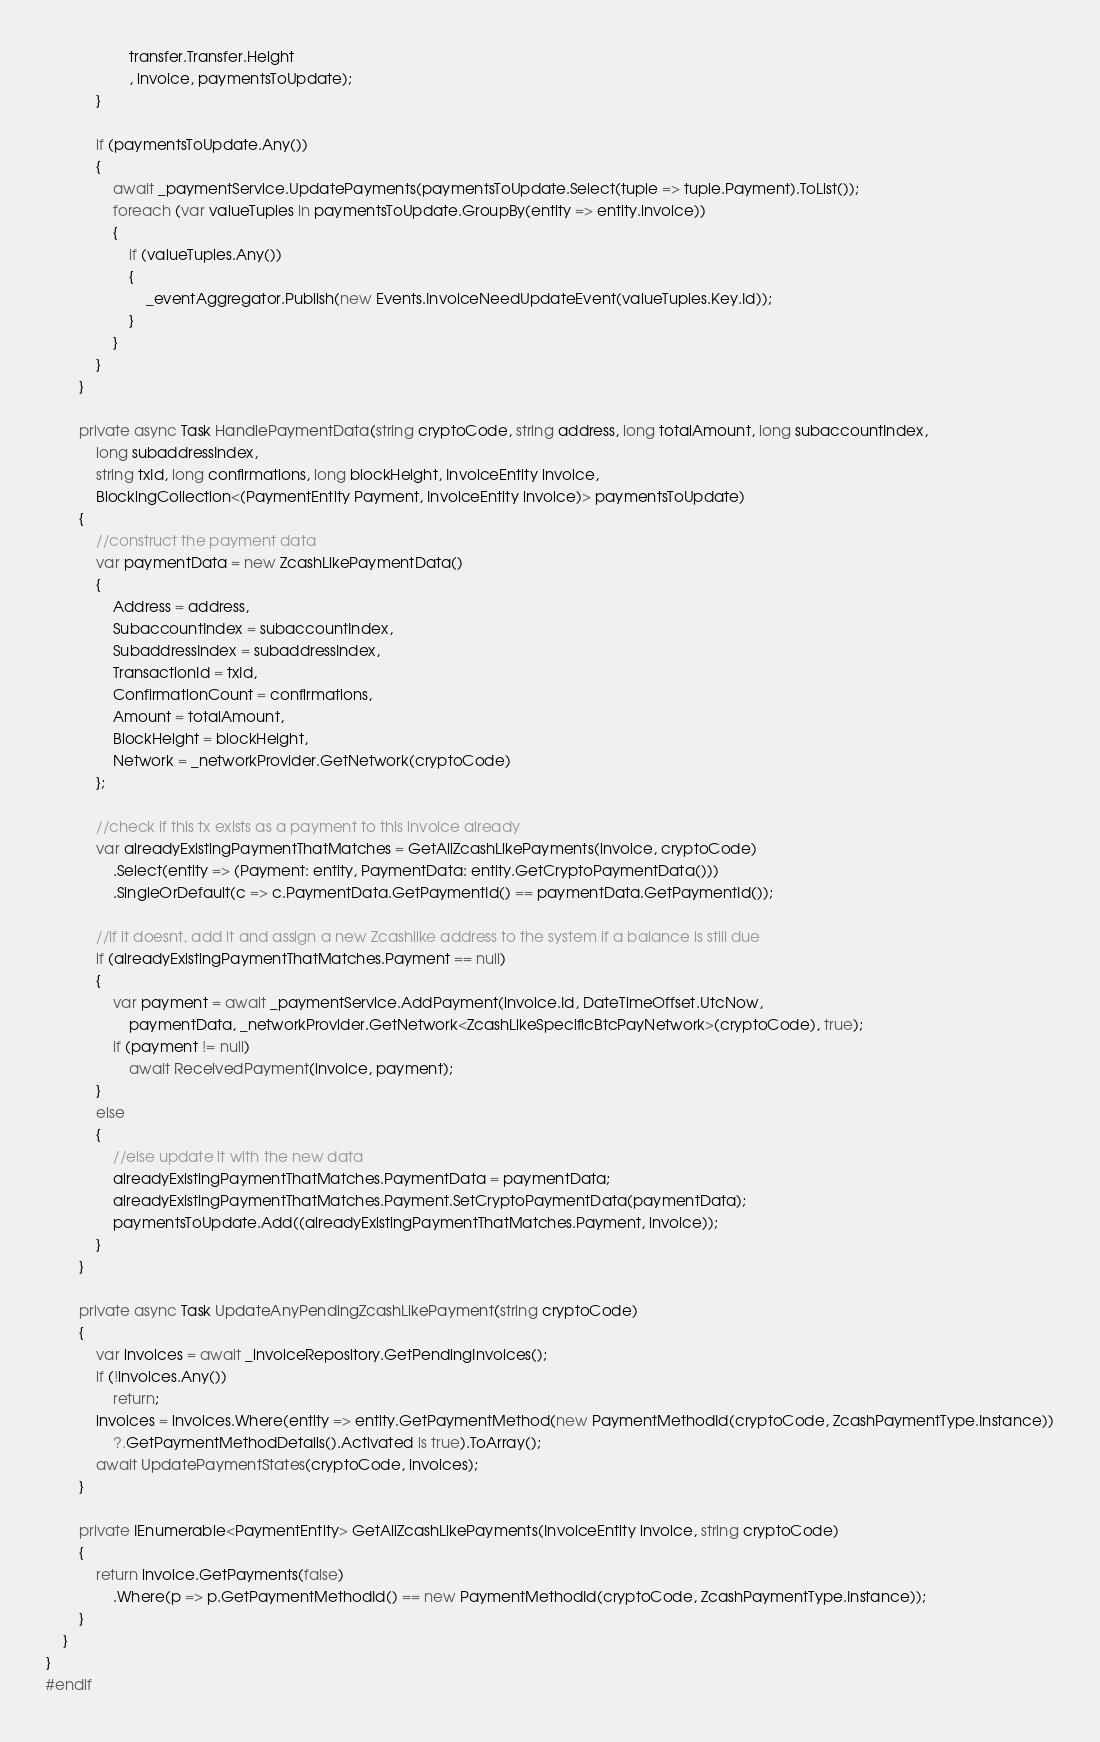<code> <loc_0><loc_0><loc_500><loc_500><_C#_>                    transfer.Transfer.Height
                    , invoice, paymentsToUpdate);
            }

            if (paymentsToUpdate.Any())
            {
                await _paymentService.UpdatePayments(paymentsToUpdate.Select(tuple => tuple.Payment).ToList());
                foreach (var valueTuples in paymentsToUpdate.GroupBy(entity => entity.invoice))
                {
                    if (valueTuples.Any())
                    {
                        _eventAggregator.Publish(new Events.InvoiceNeedUpdateEvent(valueTuples.Key.Id));
                    }
                }
            }
        }

        private async Task HandlePaymentData(string cryptoCode, string address, long totalAmount, long subaccountIndex,
            long subaddressIndex,
            string txId, long confirmations, long blockHeight, InvoiceEntity invoice,
            BlockingCollection<(PaymentEntity Payment, InvoiceEntity invoice)> paymentsToUpdate)
        {
            //construct the payment data
            var paymentData = new ZcashLikePaymentData()
            {
                Address = address,
                SubaccountIndex = subaccountIndex,
                SubaddressIndex = subaddressIndex,
                TransactionId = txId,
                ConfirmationCount = confirmations,
                Amount = totalAmount,
                BlockHeight = blockHeight,
                Network = _networkProvider.GetNetwork(cryptoCode)
            };

            //check if this tx exists as a payment to this invoice already
            var alreadyExistingPaymentThatMatches = GetAllZcashLikePayments(invoice, cryptoCode)
                .Select(entity => (Payment: entity, PaymentData: entity.GetCryptoPaymentData()))
                .SingleOrDefault(c => c.PaymentData.GetPaymentId() == paymentData.GetPaymentId());

            //if it doesnt, add it and assign a new Zcashlike address to the system if a balance is still due
            if (alreadyExistingPaymentThatMatches.Payment == null)
            {
                var payment = await _paymentService.AddPayment(invoice.Id, DateTimeOffset.UtcNow,
                    paymentData, _networkProvider.GetNetwork<ZcashLikeSpecificBtcPayNetwork>(cryptoCode), true);
                if (payment != null)
                    await ReceivedPayment(invoice, payment);
            }
            else
            {
                //else update it with the new data
                alreadyExistingPaymentThatMatches.PaymentData = paymentData;
                alreadyExistingPaymentThatMatches.Payment.SetCryptoPaymentData(paymentData);
                paymentsToUpdate.Add((alreadyExistingPaymentThatMatches.Payment, invoice));
            }
        }

        private async Task UpdateAnyPendingZcashLikePayment(string cryptoCode)
        {
            var invoices = await _invoiceRepository.GetPendingInvoices();
            if (!invoices.Any())
                return;
            invoices = invoices.Where(entity => entity.GetPaymentMethod(new PaymentMethodId(cryptoCode, ZcashPaymentType.Instance))
                ?.GetPaymentMethodDetails().Activated is true).ToArray();
            await UpdatePaymentStates(cryptoCode, invoices);
        }

        private IEnumerable<PaymentEntity> GetAllZcashLikePayments(InvoiceEntity invoice, string cryptoCode)
        {
            return invoice.GetPayments(false)
                .Where(p => p.GetPaymentMethodId() == new PaymentMethodId(cryptoCode, ZcashPaymentType.Instance));
        }
    }
}
#endif
</code> 